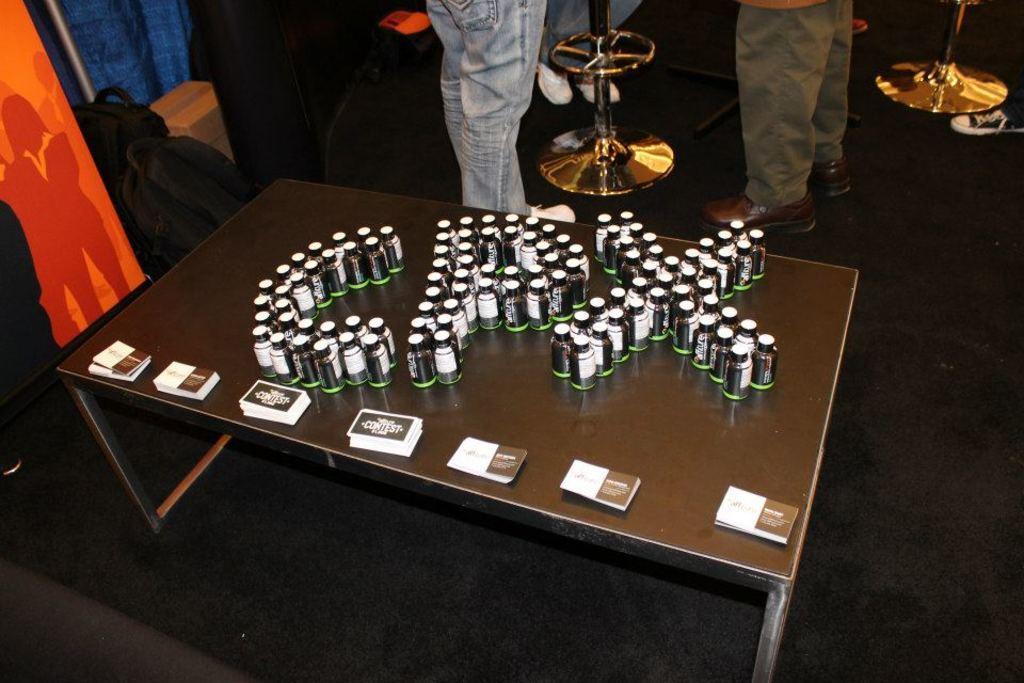Could you give a brief overview of what you see in this image? In this image I can see bottles and cards on the table. In front of it there are persons legs on the floor. To the left there is a board and bags on the floor. 